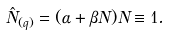Convert formula to latex. <formula><loc_0><loc_0><loc_500><loc_500>\hat { N } _ { ( q ) } = ( \alpha + \beta N ) N \equiv 1 .</formula> 